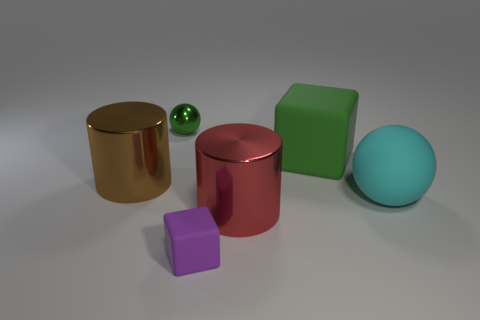There is a thing that is the same color as the small metal sphere; what size is it?
Your answer should be very brief. Large. Do the cylinder to the right of the tiny purple matte block and the brown cylinder that is left of the rubber sphere have the same material?
Keep it short and to the point. Yes. Are the large cyan sphere and the cylinder on the right side of the small purple block made of the same material?
Offer a very short reply. No. The large cylinder behind the object right of the cube that is right of the small purple matte object is what color?
Provide a succinct answer. Brown. There is a red shiny object that is the same size as the brown object; what shape is it?
Keep it short and to the point. Cylinder. Are there any other things that have the same size as the green ball?
Your response must be concise. Yes. Do the cube on the right side of the tiny purple matte block and the thing that is to the right of the large green rubber block have the same size?
Make the answer very short. Yes. There is a object on the left side of the small ball; what is its size?
Keep it short and to the point. Large. There is a ball that is the same color as the big block; what is its material?
Offer a terse response. Metal. The rubber sphere that is the same size as the brown metallic cylinder is what color?
Your answer should be very brief. Cyan. 